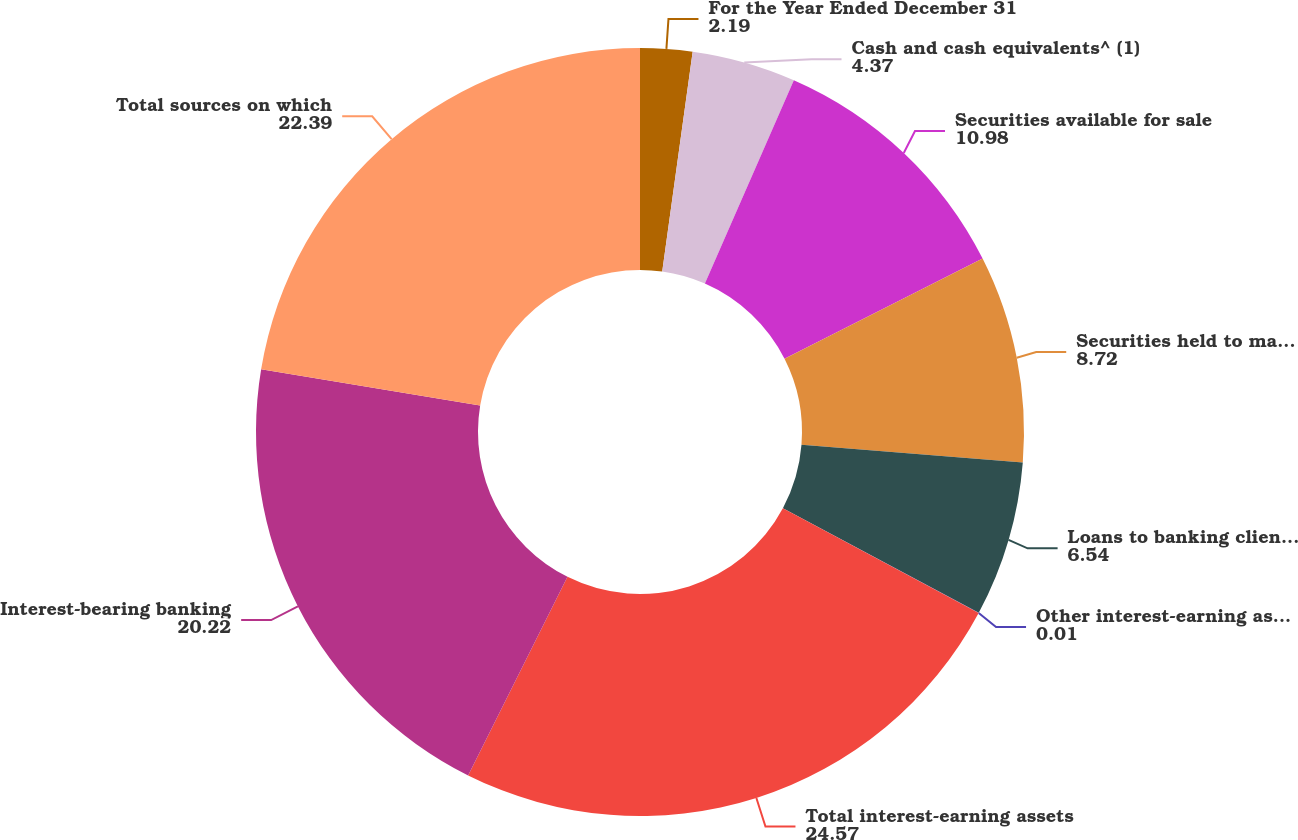Convert chart to OTSL. <chart><loc_0><loc_0><loc_500><loc_500><pie_chart><fcel>For the Year Ended December 31<fcel>Cash and cash equivalents^ (1)<fcel>Securities available for sale<fcel>Securities held to maturity<fcel>Loans to banking clients ^(3)<fcel>Other interest-earning assets<fcel>Total interest-earning assets<fcel>Interest-bearing banking<fcel>Total sources on which<nl><fcel>2.19%<fcel>4.37%<fcel>10.98%<fcel>8.72%<fcel>6.54%<fcel>0.01%<fcel>24.57%<fcel>20.22%<fcel>22.39%<nl></chart> 